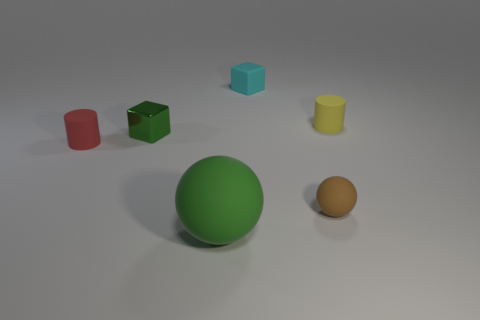Is there anything else that has the same size as the green ball?
Ensure brevity in your answer.  No. Is there any other thing that is the same material as the small red thing?
Provide a short and direct response. Yes. Is the number of green cubes right of the red object greater than the number of small cyan objects that are right of the yellow object?
Make the answer very short. Yes. What is the shape of the small brown object that is the same material as the red cylinder?
Provide a succinct answer. Sphere. How many other things are there of the same shape as the brown object?
Your answer should be compact. 1. The tiny metallic object behind the tiny red cylinder has what shape?
Ensure brevity in your answer.  Cube. What color is the metal object?
Your answer should be very brief. Green. How many other things are there of the same size as the green rubber thing?
Provide a succinct answer. 0. What material is the tiny cylinder that is behind the tiny rubber object on the left side of the green shiny thing made of?
Offer a very short reply. Rubber. There is a cyan rubber thing; is its size the same as the cube in front of the cyan matte cube?
Your response must be concise. Yes. 